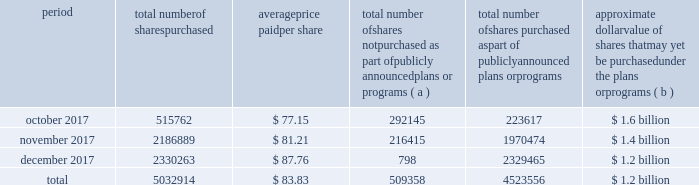Table of contents the table discloses purchases of shares of our common stock made by us or on our behalf during the fourth quarter of 2017 .
Period total number of shares purchased average price paid per share total number of shares not purchased as part of publicly announced plans or programs ( a ) total number of shares purchased as part of publicly announced plans or programs approximate dollar value of shares that may yet be purchased under the plans or programs ( b ) .
( a ) the shares reported in this column represent purchases settled in the fourth quarter of 2017 relating to ( i ) our purchases of shares in open-market transactions to meet our obligations under stock-based compensation plans , and ( ii ) our purchases of shares from our employees and non-employee directors in connection with the exercise of stock options , the vesting of restricted stock , and other stock compensation transactions in accordance with the terms of our stock-based compensation plans .
( b ) on september 21 , 2016 , we announced that our board of directors authorized our purchase of up to $ 2.5 billion of our outstanding common stock ( the 2016 program ) with no expiration date .
As of december 31 , 2017 , we had $ 1.2 billion remaining available for purchase under the 2016 program .
On january 23 , 2018 , we announced that our board of directors authorized our purchase of up to an additional $ 2.5 billion of our outstanding common stock with no expiration date. .
For the fourth quarter of 2017 what was the percent of the total number of shares purchased in november? 
Computations: (2186889 / 5032914)
Answer: 0.43452. 